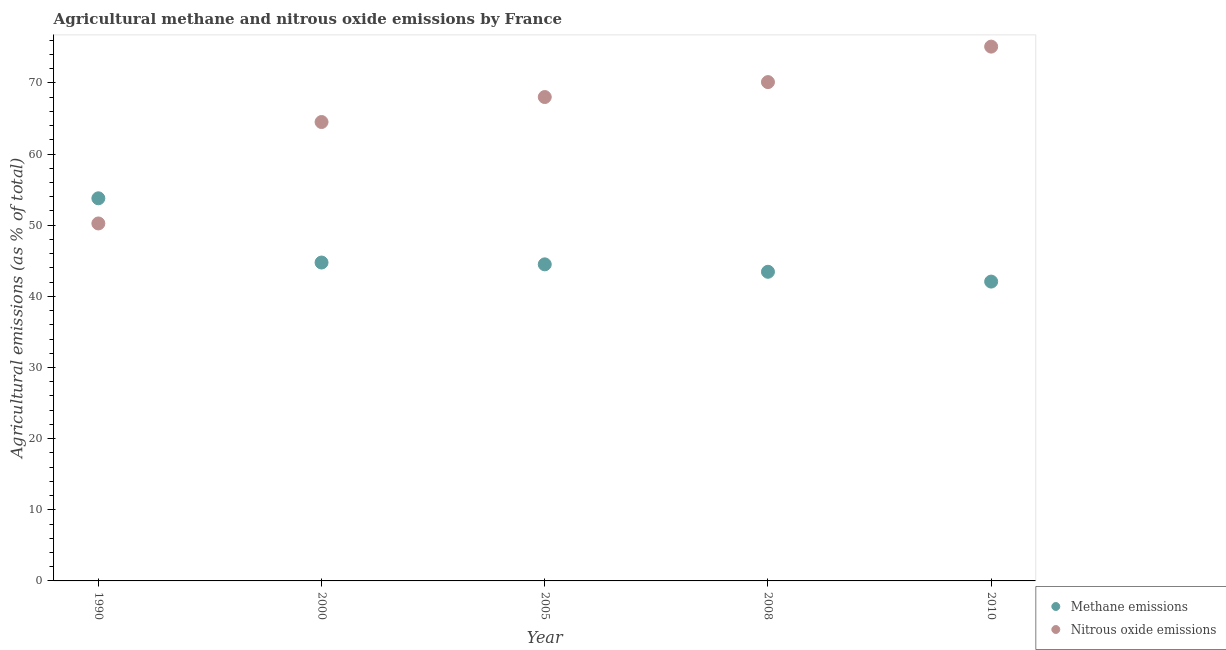Is the number of dotlines equal to the number of legend labels?
Ensure brevity in your answer.  Yes. What is the amount of methane emissions in 2000?
Ensure brevity in your answer.  44.75. Across all years, what is the maximum amount of methane emissions?
Provide a succinct answer. 53.78. Across all years, what is the minimum amount of nitrous oxide emissions?
Offer a terse response. 50.25. In which year was the amount of nitrous oxide emissions maximum?
Keep it short and to the point. 2010. In which year was the amount of methane emissions minimum?
Give a very brief answer. 2010. What is the total amount of nitrous oxide emissions in the graph?
Offer a terse response. 327.98. What is the difference between the amount of nitrous oxide emissions in 2005 and that in 2008?
Keep it short and to the point. -2.1. What is the difference between the amount of methane emissions in 2010 and the amount of nitrous oxide emissions in 2008?
Give a very brief answer. -28.04. What is the average amount of methane emissions per year?
Give a very brief answer. 45.71. In the year 2000, what is the difference between the amount of nitrous oxide emissions and amount of methane emissions?
Offer a terse response. 19.75. What is the ratio of the amount of nitrous oxide emissions in 1990 to that in 2008?
Your response must be concise. 0.72. Is the amount of methane emissions in 1990 less than that in 2005?
Offer a very short reply. No. Is the difference between the amount of nitrous oxide emissions in 1990 and 2000 greater than the difference between the amount of methane emissions in 1990 and 2000?
Your answer should be compact. No. What is the difference between the highest and the second highest amount of methane emissions?
Provide a succinct answer. 9.03. What is the difference between the highest and the lowest amount of nitrous oxide emissions?
Provide a succinct answer. 24.86. Is the sum of the amount of methane emissions in 2008 and 2010 greater than the maximum amount of nitrous oxide emissions across all years?
Your response must be concise. Yes. Does the amount of methane emissions monotonically increase over the years?
Make the answer very short. No. Is the amount of nitrous oxide emissions strictly greater than the amount of methane emissions over the years?
Provide a succinct answer. No. Is the amount of nitrous oxide emissions strictly less than the amount of methane emissions over the years?
Your response must be concise. No. How many dotlines are there?
Give a very brief answer. 2. How many years are there in the graph?
Your answer should be very brief. 5. Are the values on the major ticks of Y-axis written in scientific E-notation?
Provide a succinct answer. No. Does the graph contain any zero values?
Provide a succinct answer. No. Where does the legend appear in the graph?
Your answer should be compact. Bottom right. How many legend labels are there?
Your response must be concise. 2. What is the title of the graph?
Offer a terse response. Agricultural methane and nitrous oxide emissions by France. What is the label or title of the Y-axis?
Ensure brevity in your answer.  Agricultural emissions (as % of total). What is the Agricultural emissions (as % of total) in Methane emissions in 1990?
Make the answer very short. 53.78. What is the Agricultural emissions (as % of total) of Nitrous oxide emissions in 1990?
Ensure brevity in your answer.  50.25. What is the Agricultural emissions (as % of total) in Methane emissions in 2000?
Ensure brevity in your answer.  44.75. What is the Agricultural emissions (as % of total) of Nitrous oxide emissions in 2000?
Your answer should be very brief. 64.5. What is the Agricultural emissions (as % of total) in Methane emissions in 2005?
Keep it short and to the point. 44.5. What is the Agricultural emissions (as % of total) of Nitrous oxide emissions in 2005?
Your answer should be compact. 68.02. What is the Agricultural emissions (as % of total) in Methane emissions in 2008?
Offer a terse response. 43.45. What is the Agricultural emissions (as % of total) in Nitrous oxide emissions in 2008?
Provide a short and direct response. 70.12. What is the Agricultural emissions (as % of total) in Methane emissions in 2010?
Make the answer very short. 42.08. What is the Agricultural emissions (as % of total) of Nitrous oxide emissions in 2010?
Ensure brevity in your answer.  75.1. Across all years, what is the maximum Agricultural emissions (as % of total) in Methane emissions?
Offer a terse response. 53.78. Across all years, what is the maximum Agricultural emissions (as % of total) of Nitrous oxide emissions?
Make the answer very short. 75.1. Across all years, what is the minimum Agricultural emissions (as % of total) of Methane emissions?
Give a very brief answer. 42.08. Across all years, what is the minimum Agricultural emissions (as % of total) of Nitrous oxide emissions?
Your answer should be compact. 50.25. What is the total Agricultural emissions (as % of total) in Methane emissions in the graph?
Offer a terse response. 228.56. What is the total Agricultural emissions (as % of total) of Nitrous oxide emissions in the graph?
Provide a succinct answer. 327.98. What is the difference between the Agricultural emissions (as % of total) of Methane emissions in 1990 and that in 2000?
Provide a short and direct response. 9.03. What is the difference between the Agricultural emissions (as % of total) of Nitrous oxide emissions in 1990 and that in 2000?
Give a very brief answer. -14.26. What is the difference between the Agricultural emissions (as % of total) of Methane emissions in 1990 and that in 2005?
Keep it short and to the point. 9.28. What is the difference between the Agricultural emissions (as % of total) in Nitrous oxide emissions in 1990 and that in 2005?
Give a very brief answer. -17.77. What is the difference between the Agricultural emissions (as % of total) in Methane emissions in 1990 and that in 2008?
Offer a terse response. 10.33. What is the difference between the Agricultural emissions (as % of total) in Nitrous oxide emissions in 1990 and that in 2008?
Ensure brevity in your answer.  -19.87. What is the difference between the Agricultural emissions (as % of total) of Methane emissions in 1990 and that in 2010?
Make the answer very short. 11.71. What is the difference between the Agricultural emissions (as % of total) in Nitrous oxide emissions in 1990 and that in 2010?
Ensure brevity in your answer.  -24.86. What is the difference between the Agricultural emissions (as % of total) of Methane emissions in 2000 and that in 2005?
Your answer should be compact. 0.26. What is the difference between the Agricultural emissions (as % of total) of Nitrous oxide emissions in 2000 and that in 2005?
Make the answer very short. -3.51. What is the difference between the Agricultural emissions (as % of total) of Methane emissions in 2000 and that in 2008?
Make the answer very short. 1.3. What is the difference between the Agricultural emissions (as % of total) in Nitrous oxide emissions in 2000 and that in 2008?
Your answer should be very brief. -5.61. What is the difference between the Agricultural emissions (as % of total) of Methane emissions in 2000 and that in 2010?
Keep it short and to the point. 2.68. What is the difference between the Agricultural emissions (as % of total) of Nitrous oxide emissions in 2000 and that in 2010?
Your answer should be compact. -10.6. What is the difference between the Agricultural emissions (as % of total) in Methane emissions in 2005 and that in 2008?
Give a very brief answer. 1.04. What is the difference between the Agricultural emissions (as % of total) of Nitrous oxide emissions in 2005 and that in 2008?
Your answer should be very brief. -2.1. What is the difference between the Agricultural emissions (as % of total) in Methane emissions in 2005 and that in 2010?
Your answer should be compact. 2.42. What is the difference between the Agricultural emissions (as % of total) in Nitrous oxide emissions in 2005 and that in 2010?
Ensure brevity in your answer.  -7.09. What is the difference between the Agricultural emissions (as % of total) of Methane emissions in 2008 and that in 2010?
Your answer should be compact. 1.38. What is the difference between the Agricultural emissions (as % of total) in Nitrous oxide emissions in 2008 and that in 2010?
Provide a short and direct response. -4.99. What is the difference between the Agricultural emissions (as % of total) of Methane emissions in 1990 and the Agricultural emissions (as % of total) of Nitrous oxide emissions in 2000?
Provide a succinct answer. -10.72. What is the difference between the Agricultural emissions (as % of total) of Methane emissions in 1990 and the Agricultural emissions (as % of total) of Nitrous oxide emissions in 2005?
Your response must be concise. -14.23. What is the difference between the Agricultural emissions (as % of total) in Methane emissions in 1990 and the Agricultural emissions (as % of total) in Nitrous oxide emissions in 2008?
Offer a terse response. -16.33. What is the difference between the Agricultural emissions (as % of total) in Methane emissions in 1990 and the Agricultural emissions (as % of total) in Nitrous oxide emissions in 2010?
Keep it short and to the point. -21.32. What is the difference between the Agricultural emissions (as % of total) of Methane emissions in 2000 and the Agricultural emissions (as % of total) of Nitrous oxide emissions in 2005?
Your response must be concise. -23.26. What is the difference between the Agricultural emissions (as % of total) in Methane emissions in 2000 and the Agricultural emissions (as % of total) in Nitrous oxide emissions in 2008?
Ensure brevity in your answer.  -25.36. What is the difference between the Agricultural emissions (as % of total) in Methane emissions in 2000 and the Agricultural emissions (as % of total) in Nitrous oxide emissions in 2010?
Give a very brief answer. -30.35. What is the difference between the Agricultural emissions (as % of total) of Methane emissions in 2005 and the Agricultural emissions (as % of total) of Nitrous oxide emissions in 2008?
Provide a short and direct response. -25.62. What is the difference between the Agricultural emissions (as % of total) in Methane emissions in 2005 and the Agricultural emissions (as % of total) in Nitrous oxide emissions in 2010?
Provide a succinct answer. -30.6. What is the difference between the Agricultural emissions (as % of total) of Methane emissions in 2008 and the Agricultural emissions (as % of total) of Nitrous oxide emissions in 2010?
Provide a succinct answer. -31.65. What is the average Agricultural emissions (as % of total) in Methane emissions per year?
Your answer should be compact. 45.71. What is the average Agricultural emissions (as % of total) in Nitrous oxide emissions per year?
Give a very brief answer. 65.6. In the year 1990, what is the difference between the Agricultural emissions (as % of total) of Methane emissions and Agricultural emissions (as % of total) of Nitrous oxide emissions?
Ensure brevity in your answer.  3.54. In the year 2000, what is the difference between the Agricultural emissions (as % of total) in Methane emissions and Agricultural emissions (as % of total) in Nitrous oxide emissions?
Provide a short and direct response. -19.75. In the year 2005, what is the difference between the Agricultural emissions (as % of total) in Methane emissions and Agricultural emissions (as % of total) in Nitrous oxide emissions?
Your response must be concise. -23.52. In the year 2008, what is the difference between the Agricultural emissions (as % of total) of Methane emissions and Agricultural emissions (as % of total) of Nitrous oxide emissions?
Your answer should be very brief. -26.66. In the year 2010, what is the difference between the Agricultural emissions (as % of total) in Methane emissions and Agricultural emissions (as % of total) in Nitrous oxide emissions?
Offer a very short reply. -33.03. What is the ratio of the Agricultural emissions (as % of total) of Methane emissions in 1990 to that in 2000?
Your response must be concise. 1.2. What is the ratio of the Agricultural emissions (as % of total) of Nitrous oxide emissions in 1990 to that in 2000?
Give a very brief answer. 0.78. What is the ratio of the Agricultural emissions (as % of total) of Methane emissions in 1990 to that in 2005?
Your answer should be very brief. 1.21. What is the ratio of the Agricultural emissions (as % of total) of Nitrous oxide emissions in 1990 to that in 2005?
Offer a very short reply. 0.74. What is the ratio of the Agricultural emissions (as % of total) of Methane emissions in 1990 to that in 2008?
Your answer should be compact. 1.24. What is the ratio of the Agricultural emissions (as % of total) of Nitrous oxide emissions in 1990 to that in 2008?
Keep it short and to the point. 0.72. What is the ratio of the Agricultural emissions (as % of total) of Methane emissions in 1990 to that in 2010?
Your answer should be very brief. 1.28. What is the ratio of the Agricultural emissions (as % of total) in Nitrous oxide emissions in 1990 to that in 2010?
Keep it short and to the point. 0.67. What is the ratio of the Agricultural emissions (as % of total) in Nitrous oxide emissions in 2000 to that in 2005?
Provide a succinct answer. 0.95. What is the ratio of the Agricultural emissions (as % of total) in Methane emissions in 2000 to that in 2008?
Ensure brevity in your answer.  1.03. What is the ratio of the Agricultural emissions (as % of total) of Nitrous oxide emissions in 2000 to that in 2008?
Offer a terse response. 0.92. What is the ratio of the Agricultural emissions (as % of total) in Methane emissions in 2000 to that in 2010?
Offer a very short reply. 1.06. What is the ratio of the Agricultural emissions (as % of total) of Nitrous oxide emissions in 2000 to that in 2010?
Make the answer very short. 0.86. What is the ratio of the Agricultural emissions (as % of total) of Methane emissions in 2005 to that in 2008?
Offer a very short reply. 1.02. What is the ratio of the Agricultural emissions (as % of total) in Nitrous oxide emissions in 2005 to that in 2008?
Make the answer very short. 0.97. What is the ratio of the Agricultural emissions (as % of total) of Methane emissions in 2005 to that in 2010?
Your answer should be compact. 1.06. What is the ratio of the Agricultural emissions (as % of total) of Nitrous oxide emissions in 2005 to that in 2010?
Your answer should be very brief. 0.91. What is the ratio of the Agricultural emissions (as % of total) of Methane emissions in 2008 to that in 2010?
Provide a succinct answer. 1.03. What is the ratio of the Agricultural emissions (as % of total) of Nitrous oxide emissions in 2008 to that in 2010?
Ensure brevity in your answer.  0.93. What is the difference between the highest and the second highest Agricultural emissions (as % of total) in Methane emissions?
Give a very brief answer. 9.03. What is the difference between the highest and the second highest Agricultural emissions (as % of total) in Nitrous oxide emissions?
Offer a terse response. 4.99. What is the difference between the highest and the lowest Agricultural emissions (as % of total) in Methane emissions?
Your response must be concise. 11.71. What is the difference between the highest and the lowest Agricultural emissions (as % of total) of Nitrous oxide emissions?
Keep it short and to the point. 24.86. 